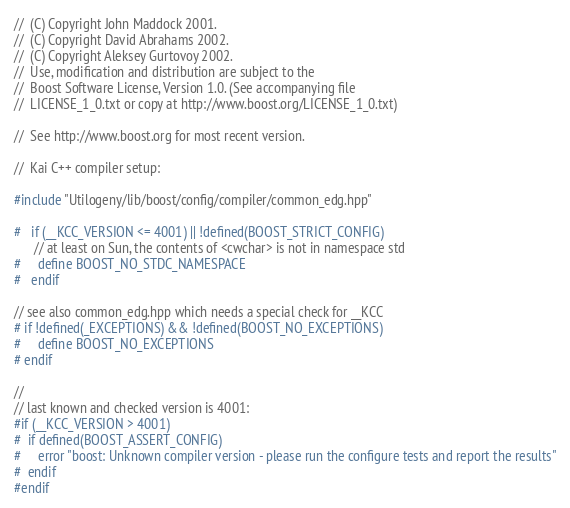<code> <loc_0><loc_0><loc_500><loc_500><_C++_>//  (C) Copyright John Maddock 2001. 
//  (C) Copyright David Abrahams 2002. 
//  (C) Copyright Aleksey Gurtovoy 2002. 
//  Use, modification and distribution are subject to the 
//  Boost Software License, Version 1.0. (See accompanying file 
//  LICENSE_1_0.txt or copy at http://www.boost.org/LICENSE_1_0.txt)

//  See http://www.boost.org for most recent version.

//  Kai C++ compiler setup:

#include "Utilogeny/lib/boost/config/compiler/common_edg.hpp"

#   if (__KCC_VERSION <= 4001) || !defined(BOOST_STRICT_CONFIG)
      // at least on Sun, the contents of <cwchar> is not in namespace std
#     define BOOST_NO_STDC_NAMESPACE
#   endif

// see also common_edg.hpp which needs a special check for __KCC
# if !defined(_EXCEPTIONS) && !defined(BOOST_NO_EXCEPTIONS)
#     define BOOST_NO_EXCEPTIONS
# endif

//
// last known and checked version is 4001:
#if (__KCC_VERSION > 4001)
#  if defined(BOOST_ASSERT_CONFIG)
#     error "boost: Unknown compiler version - please run the configure tests and report the results"
#  endif
#endif



</code> 